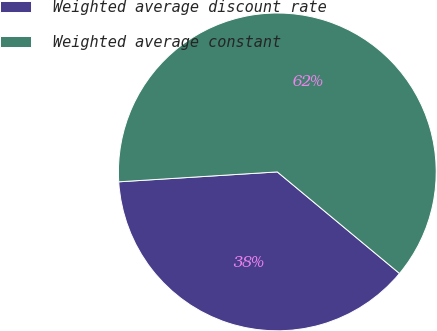Convert chart to OTSL. <chart><loc_0><loc_0><loc_500><loc_500><pie_chart><fcel>Weighted average discount rate<fcel>Weighted average constant<nl><fcel>37.97%<fcel>62.03%<nl></chart> 